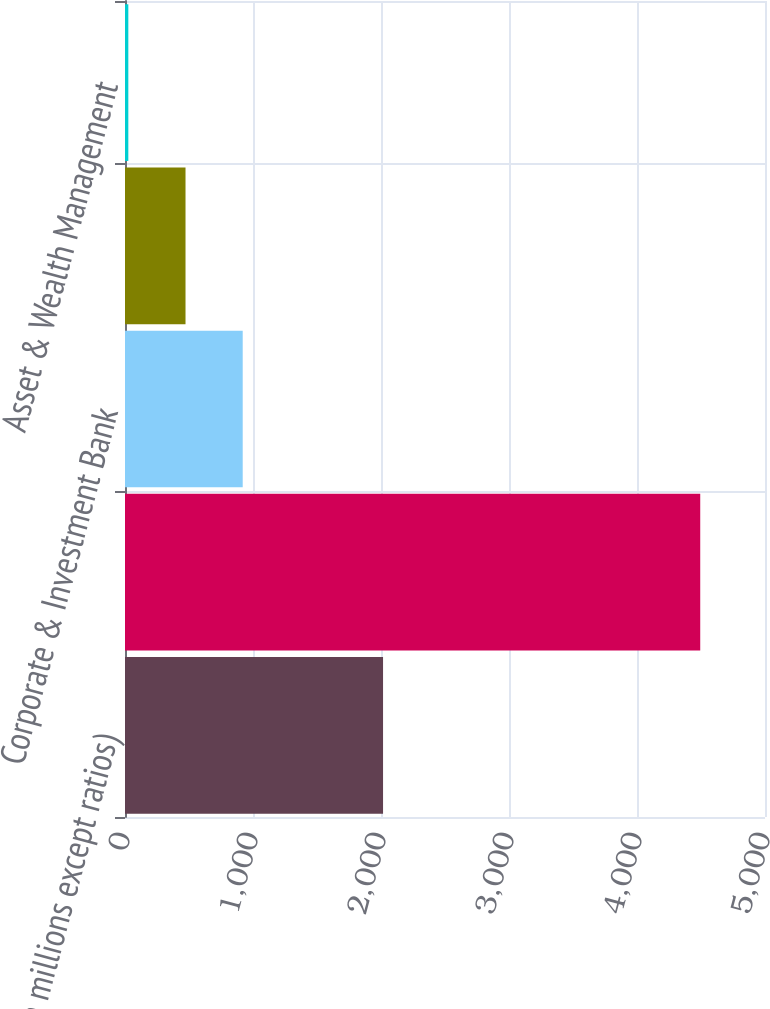Convert chart. <chart><loc_0><loc_0><loc_500><loc_500><bar_chart><fcel>(in millions except ratios)<fcel>Consumer & Community Banking<fcel>Corporate & Investment Bank<fcel>Commercial Banking<fcel>Asset & Wealth Management<nl><fcel>2016<fcel>4494<fcel>919.6<fcel>472.8<fcel>26<nl></chart> 